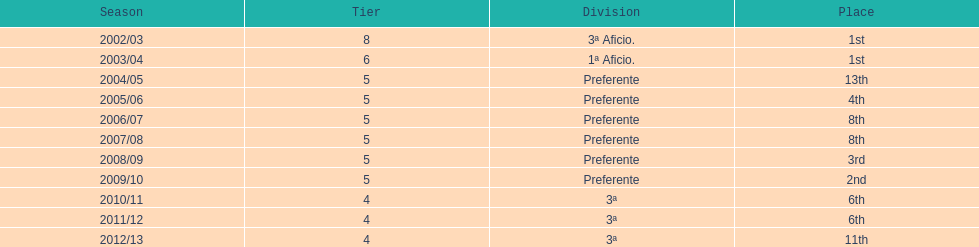For what duration was the team in the top position? 2 years. 